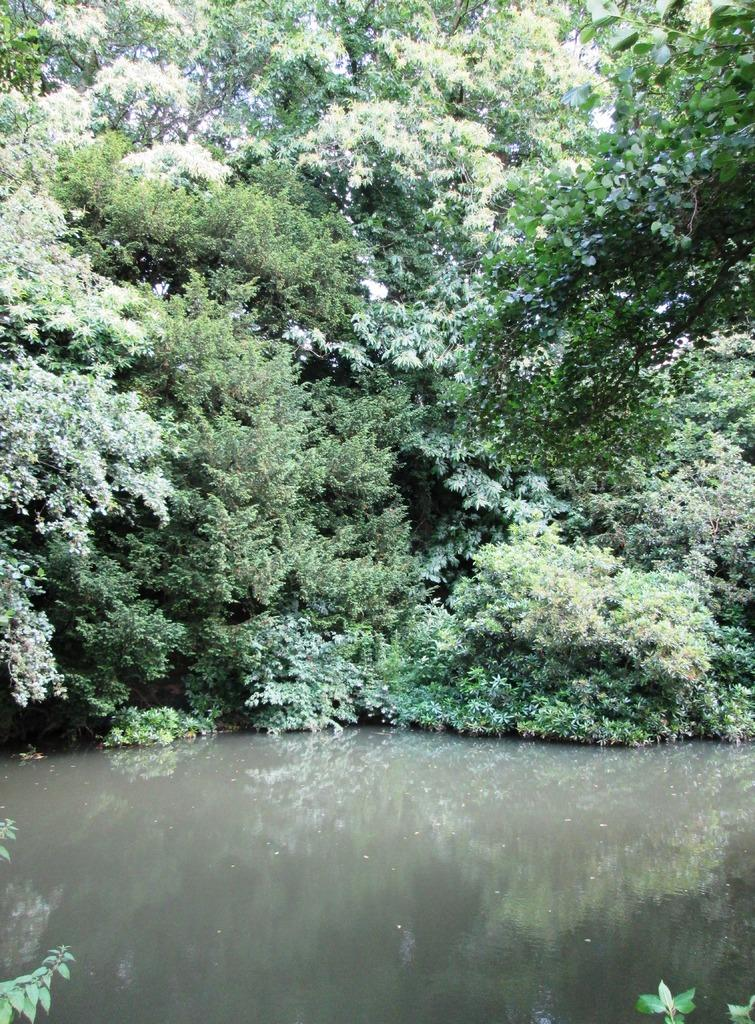What can be seen in the image? There is water visible in the image. What is in the background of the image? There are trees in the background of the image. What type of building can be seen in the image? There is no building present in the image; it only features water and trees in the background. What color is the collar on the person in the image? There is no person or collar present in the image. 